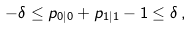<formula> <loc_0><loc_0><loc_500><loc_500>- \delta \leq p _ { 0 | 0 } + p _ { 1 | 1 } - 1 \leq \delta \, ,</formula> 